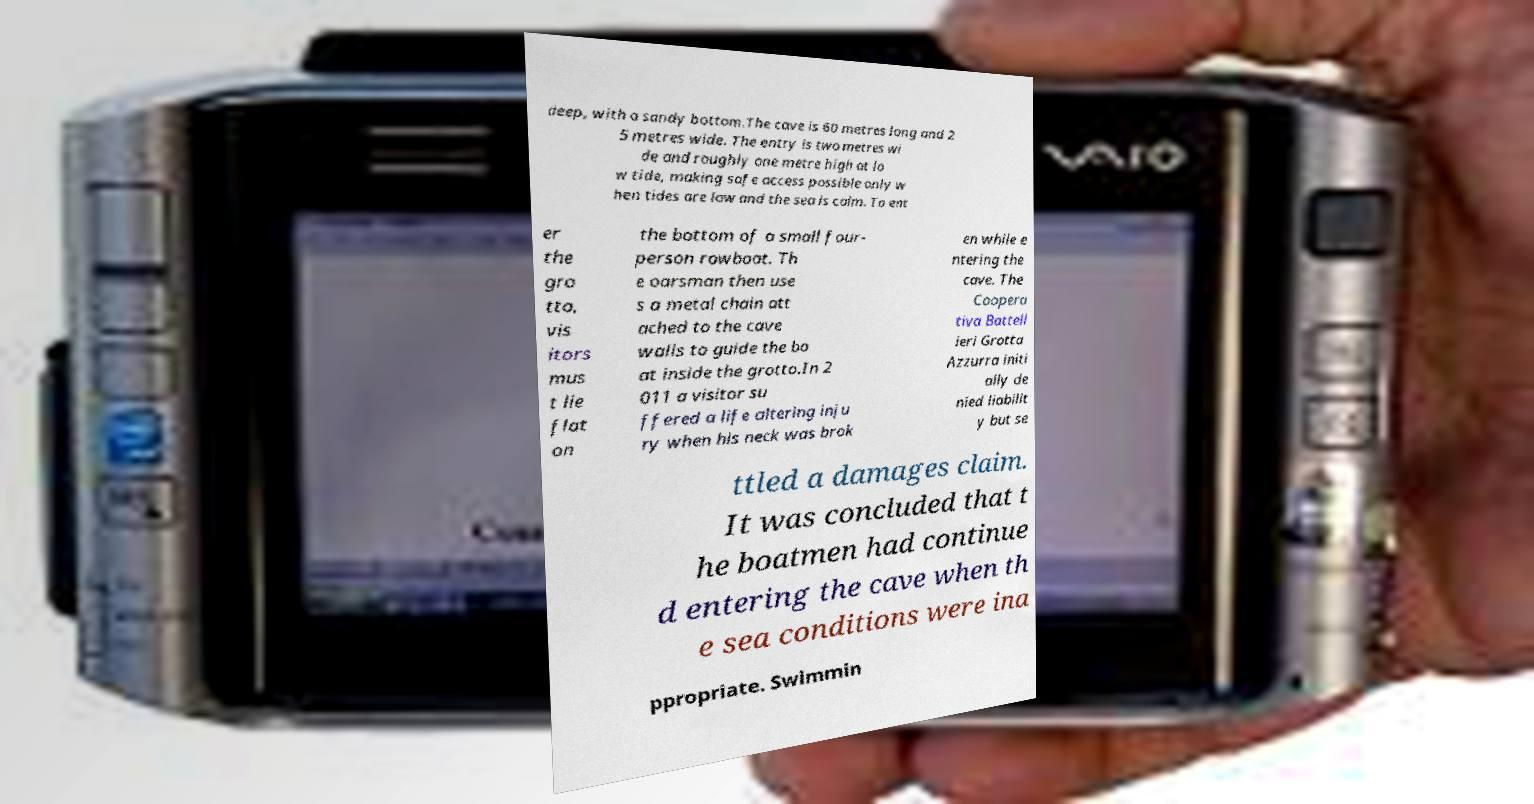Could you assist in decoding the text presented in this image and type it out clearly? deep, with a sandy bottom.The cave is 60 metres long and 2 5 metres wide. The entry is two metres wi de and roughly one metre high at lo w tide, making safe access possible only w hen tides are low and the sea is calm. To ent er the gro tto, vis itors mus t lie flat on the bottom of a small four- person rowboat. Th e oarsman then use s a metal chain att ached to the cave walls to guide the bo at inside the grotto.In 2 011 a visitor su ffered a life altering inju ry when his neck was brok en while e ntering the cave. The Coopera tiva Battell ieri Grotta Azzurra initi ally de nied liabilit y but se ttled a damages claim. It was concluded that t he boatmen had continue d entering the cave when th e sea conditions were ina ppropriate. Swimmin 